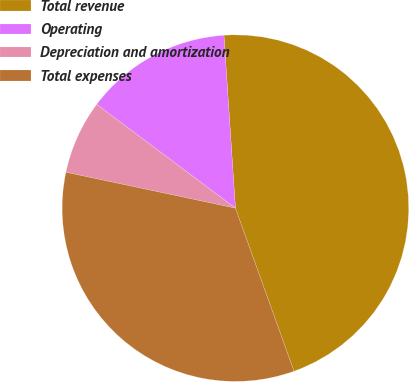Convert chart to OTSL. <chart><loc_0><loc_0><loc_500><loc_500><pie_chart><fcel>Total revenue<fcel>Operating<fcel>Depreciation and amortization<fcel>Total expenses<nl><fcel>45.57%<fcel>13.72%<fcel>6.9%<fcel>33.81%<nl></chart> 